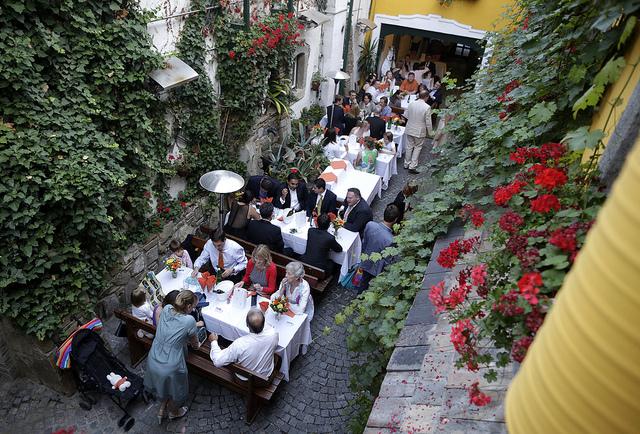What color combination are the flowers on the tables?
Answer briefly. Orange and yellow. Are all of the people part of the same group?
Answer briefly. Yes. Is this picture taken in the United States?
Write a very short answer. No. Is this a restaurant or a party?
Give a very brief answer. Restaurant. 